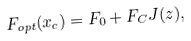Convert formula to latex. <formula><loc_0><loc_0><loc_500><loc_500>F _ { o p t } ( x _ { c } ) = F _ { 0 } + F _ { C } J ( z ) ,</formula> 